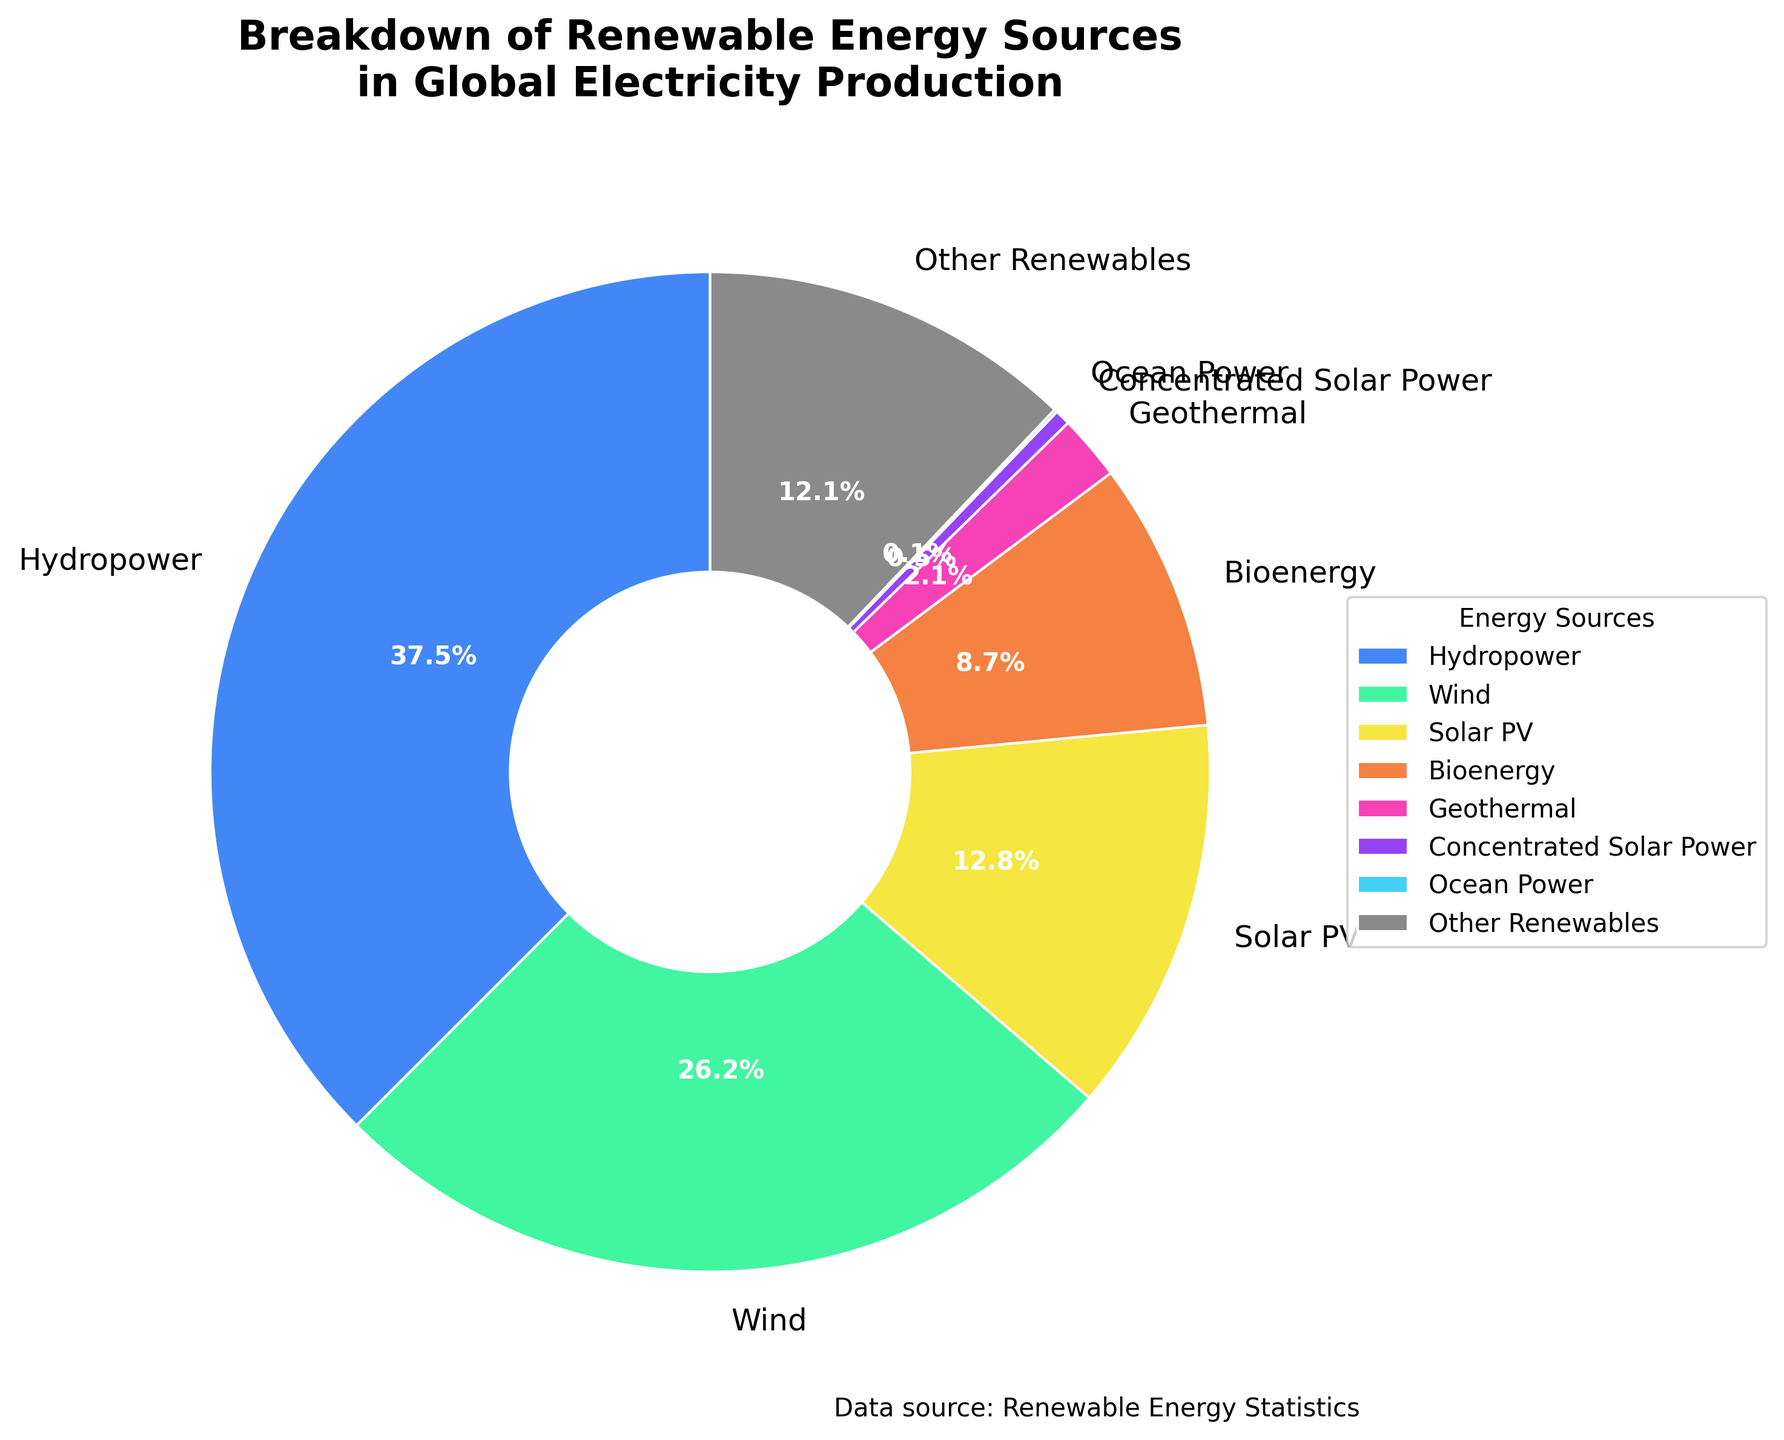What percentage of global electricity production comes from wind energy? The pie chart shows different renewable energy sources and their respective percentages. Look for "Wind" in the chart and refer to its percentage, which is explicitly labeled.
Answer: 26.2% How does the contribution of solar PV compare to bioenergy? Identify the segments labeled "Solar PV" and "Bioenergy" in the chart. Solar PV is 12.8%, and Bioenergy is 8.7%. Compare these two values.
Answer: Solar PV is higher than Bioenergy Which energy source contributes the most to global electricity production? Look for the largest segment in the pie chart. The labeled percentage will help identify the energy source.
Answer: Hydropower What is the combined percentage of solar PV and concentrated solar power? Identify the percentages for "Solar PV" (12.8%) and "Concentrated Solar Power" (0.5%). Sum these values: 12.8% + 0.5% = 13.3%.
Answer: 13.3% How much more does hydropower contribute compared to wind energy? Identify the percentages for "Hydropower" (37.5%) and "Wind" (26.2%). Subtract the percentage of Wind from Hydropower: 37.5% - 26.2% = 11.3%.
Answer: 11.3% Which energy sources contribute less than 5% to global electricity production? Identify the segments in the pie chart with percentages less than 5%. These are Geothermal (2.1%), Concentrated Solar Power (0.5%), and Ocean Power (0.1%).
Answer: Geothermal, Concentrated Solar Power, Ocean Power Are there more energy sources contributing above or below 10% to global electricity production? Count the segments contributing above 10% and those below 10%. Above 10%: Hydropower, Wind, Solar PV (3 sources). Below 10%: Bioenergy, Geothermal, Concentrated Solar Power, Ocean Power, Other Renewables (5 sources). Compare the counts.
Answer: Below 10% What is the second least contributing energy source after Ocean Power? Identify the segments with the smallest percentages. Ocean Power is 0.1%, and the next smallest is Concentrated Solar Power at 0.5%.
Answer: Concentrated Solar Power What is the total percentage contribution of all "Other Renewables"? Identify the percentage labeled "Other Renewables" in the pie chart, which directly gives this information.
Answer: 12.1% How much more does solar PV contribute compared to geothermal energy? Identify the percentages for "Solar PV" (12.8%) and "Geothermal" (2.1%). Subtract the percentage of Geothermal from Solar PV: 12.8% - 2.1% = 10.7%.
Answer: 10.7% 